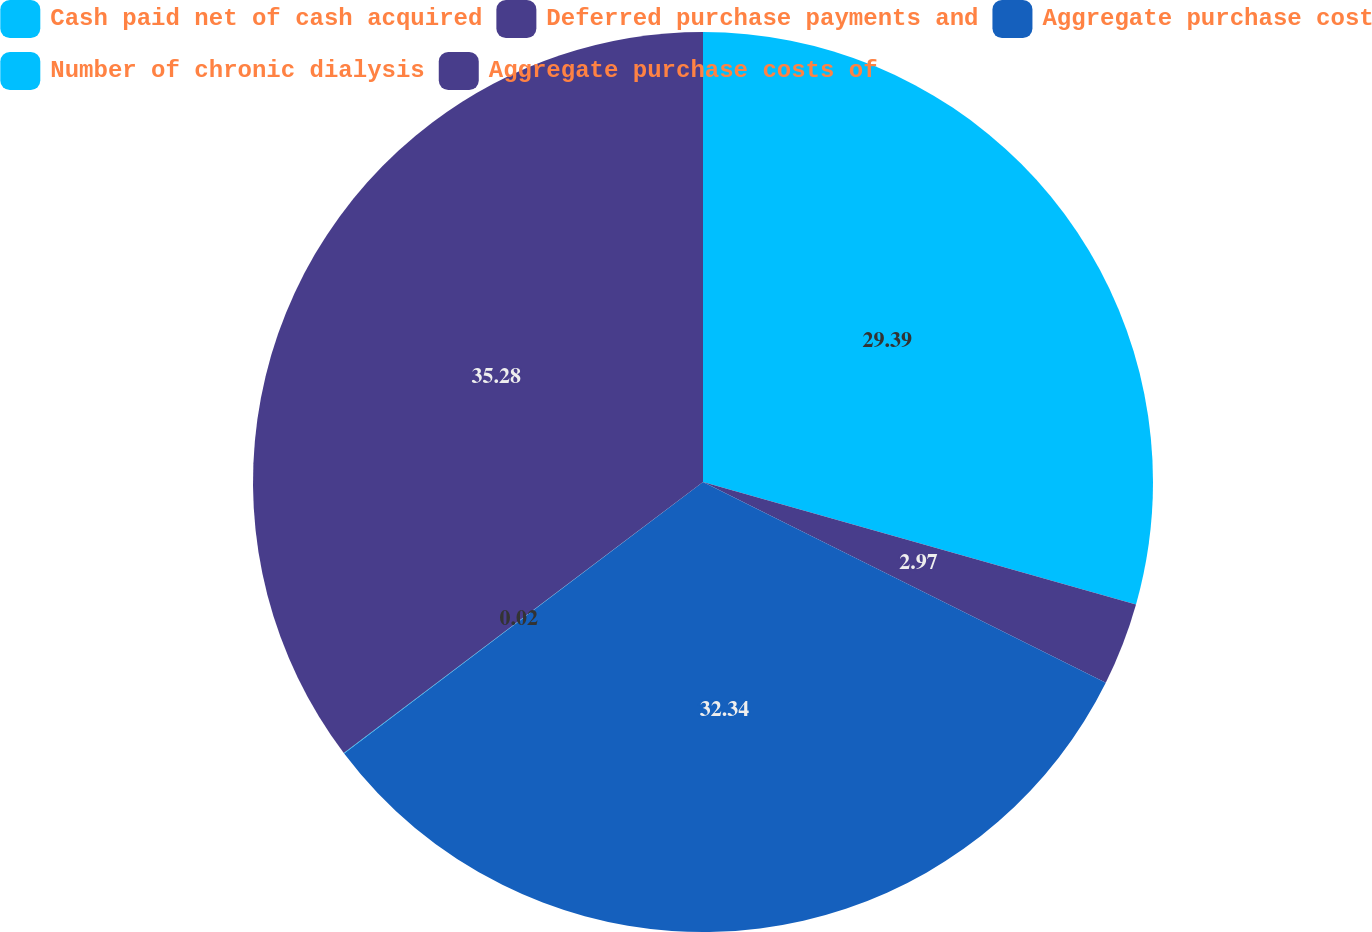Convert chart. <chart><loc_0><loc_0><loc_500><loc_500><pie_chart><fcel>Cash paid net of cash acquired<fcel>Deferred purchase payments and<fcel>Aggregate purchase cost<fcel>Number of chronic dialysis<fcel>Aggregate purchase costs of<nl><fcel>29.39%<fcel>2.97%<fcel>32.34%<fcel>0.02%<fcel>35.29%<nl></chart> 